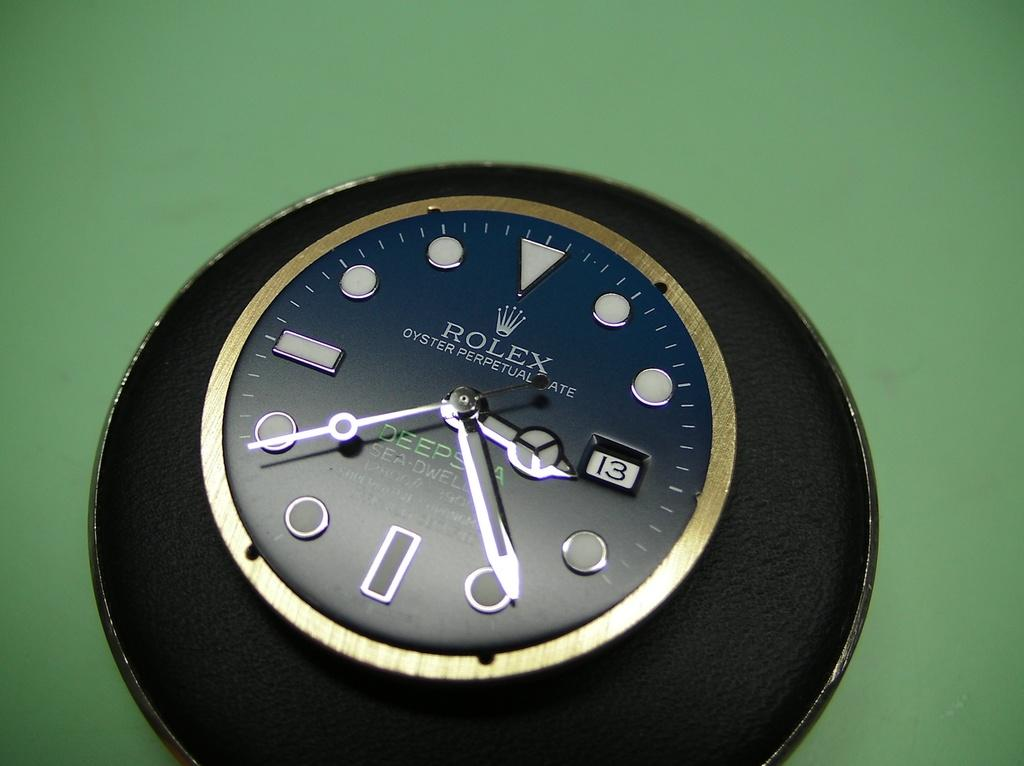Provide a one-sentence caption for the provided image. A black Rolex Oyster Perpetual Rate Deepsea Superlative Chronomatic clock. 